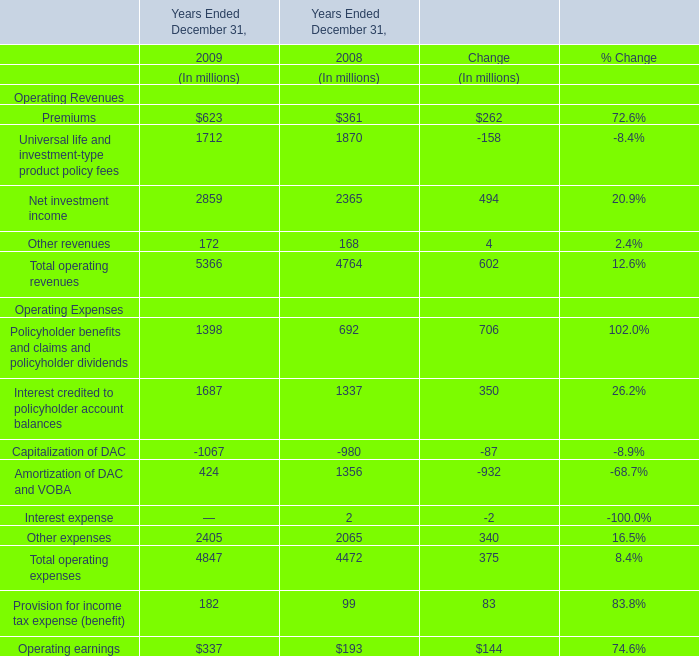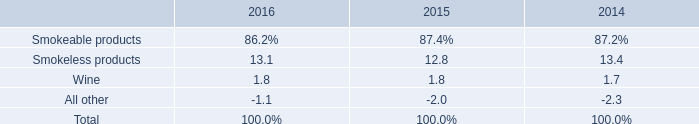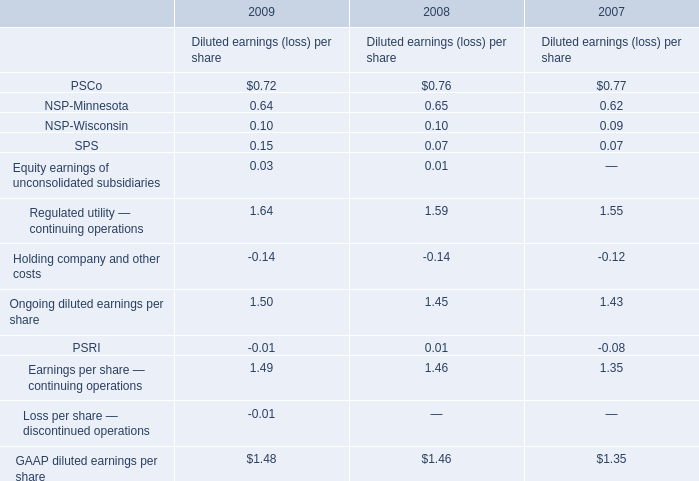what is the total units of shipment volume for cigars in 2015 , in billions? 
Computations: (1.4 / (100 + 5.9%))
Answer: 0.01399. 